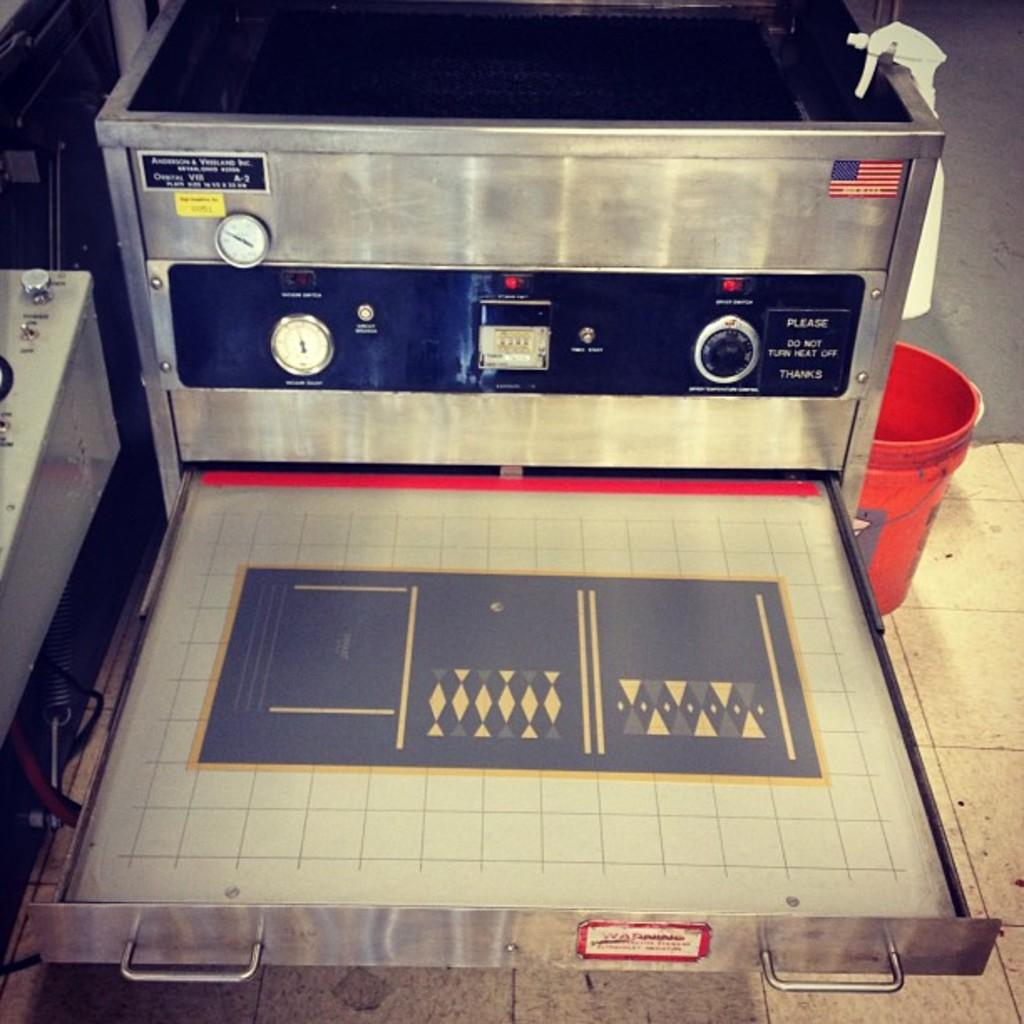<image>
Relay a brief, clear account of the picture shown. A device thanking you for not turning the heat off 